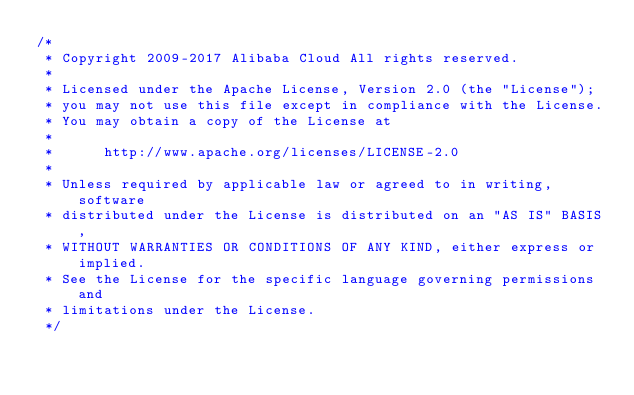<code> <loc_0><loc_0><loc_500><loc_500><_C++_>/*
 * Copyright 2009-2017 Alibaba Cloud All rights reserved.
 * 
 * Licensed under the Apache License, Version 2.0 (the "License");
 * you may not use this file except in compliance with the License.
 * You may obtain a copy of the License at
 * 
 *      http://www.apache.org/licenses/LICENSE-2.0
 * 
 * Unless required by applicable law or agreed to in writing, software
 * distributed under the License is distributed on an "AS IS" BASIS,
 * WITHOUT WARRANTIES OR CONDITIONS OF ANY KIND, either express or implied.
 * See the License for the specific language governing permissions and
 * limitations under the License.
 */
</code> 